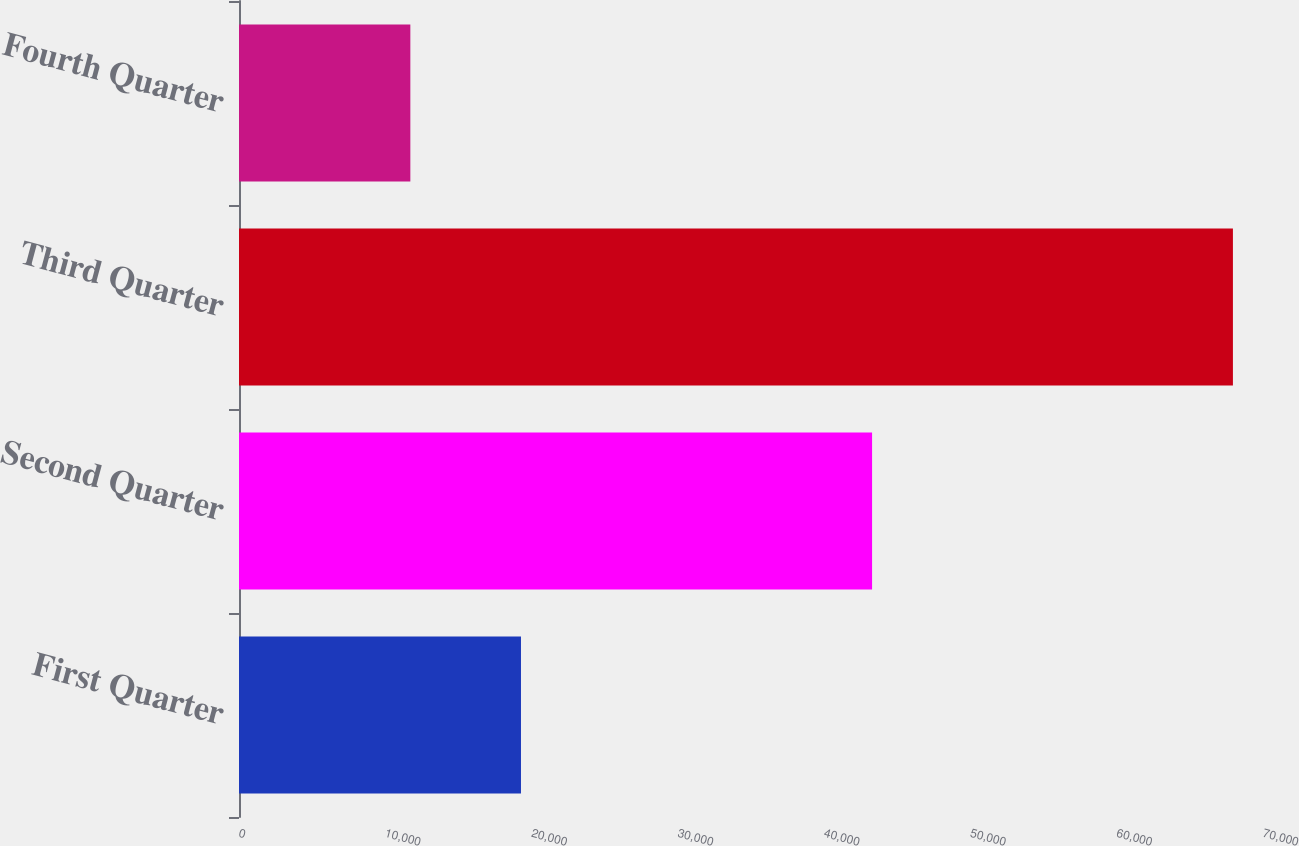Convert chart. <chart><loc_0><loc_0><loc_500><loc_500><bar_chart><fcel>First Quarter<fcel>Second Quarter<fcel>Third Quarter<fcel>Fourth Quarter<nl><fcel>19276<fcel>43277<fcel>67944<fcel>11713<nl></chart> 